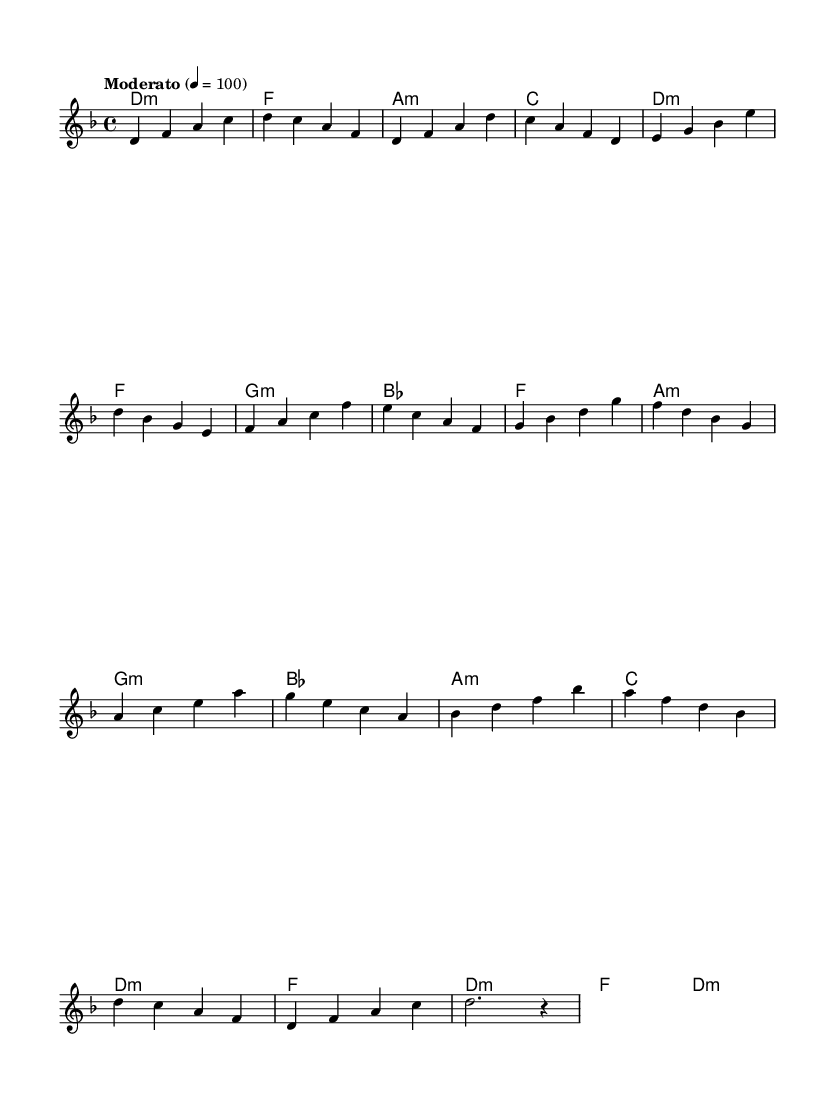What is the key signature of this music? The key signature indicates that the music is in D minor, as it includes the B flat which is characteristic of the D minor scale.
Answer: D minor What is the time signature of this music? The time signature is found at the beginning of the score, where it shows 4/4, meaning there are four beats in each measure and the quarter note gets one beat.
Answer: 4/4 What is the tempo marking of this music? The tempo marking "Moderato" is indicated in the score, with a tempo indication of 100 beats per minute, which describes the speed of the music.
Answer: Moderato How many sections are in the music? By analyzing the structure, the music contains five sections: Intro, Verse, Chorus, Bridge, and Outro, each with distinct musical ideas.
Answer: Five What is the chord for the Chorus section? In the Chorus, each measure is defined by the chords: F, A minor, G minor, and B flat, which contribute to the harmonic progression.
Answer: F, A minor, G minor, B flat What type of fusion elements can you identify in this music? The blending of orchestral elements represented by the melodic line and harmonies with electronic elements may be implied, though not explicitly stated in the sheet music. This represents the fusion style characteristic of this composition.
Answer: Orchestral and electronic elements What is the note count in the Bridge section? To find the note count, we tally the notes in the Bridge which includes measures with notes: A, C, E, G, and B, adding them up leads to a total of 16 notes in the Bridge section.
Answer: 16 